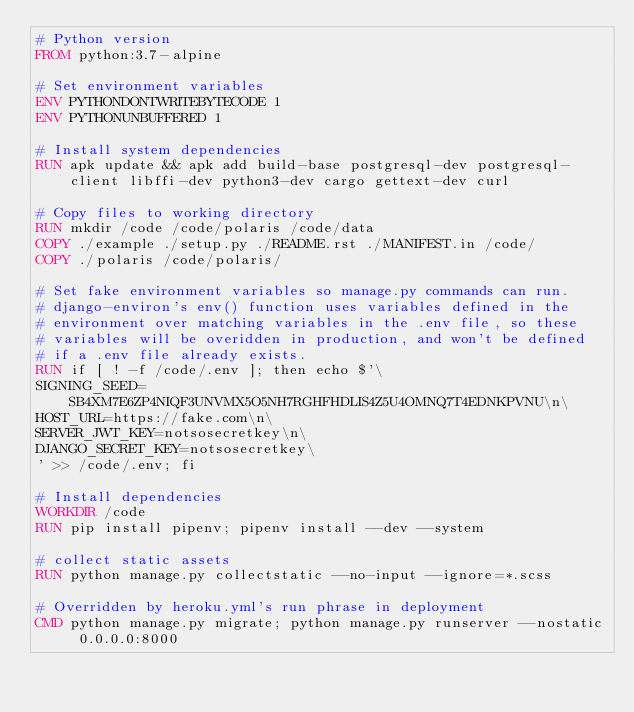Convert code to text. <code><loc_0><loc_0><loc_500><loc_500><_Dockerfile_># Python version
FROM python:3.7-alpine

# Set environment variables
ENV PYTHONDONTWRITEBYTECODE 1
ENV PYTHONUNBUFFERED 1

# Install system dependencies
RUN apk update && apk add build-base postgresql-dev postgresql-client libffi-dev python3-dev cargo gettext-dev curl

# Copy files to working directory
RUN mkdir /code /code/polaris /code/data
COPY ./example ./setup.py ./README.rst ./MANIFEST.in /code/
COPY ./polaris /code/polaris/

# Set fake environment variables so manage.py commands can run.
# django-environ's env() function uses variables defined in the
# environment over matching variables in the .env file, so these
# variables will be overidden in production, and won't be defined
# if a .env file already exists.
RUN if [ ! -f /code/.env ]; then echo $'\
SIGNING_SEED=SB4XM7E6ZP4NIQF3UNVMX5O5NH7RGHFHDLIS4Z5U4OMNQ7T4EDNKPVNU\n\
HOST_URL=https://fake.com\n\
SERVER_JWT_KEY=notsosecretkey\n\
DJANGO_SECRET_KEY=notsosecretkey\
' >> /code/.env; fi

# Install dependencies
WORKDIR /code
RUN pip install pipenv; pipenv install --dev --system

# collect static assets
RUN python manage.py collectstatic --no-input --ignore=*.scss

# Overridden by heroku.yml's run phrase in deployment
CMD python manage.py migrate; python manage.py runserver --nostatic 0.0.0.0:8000</code> 